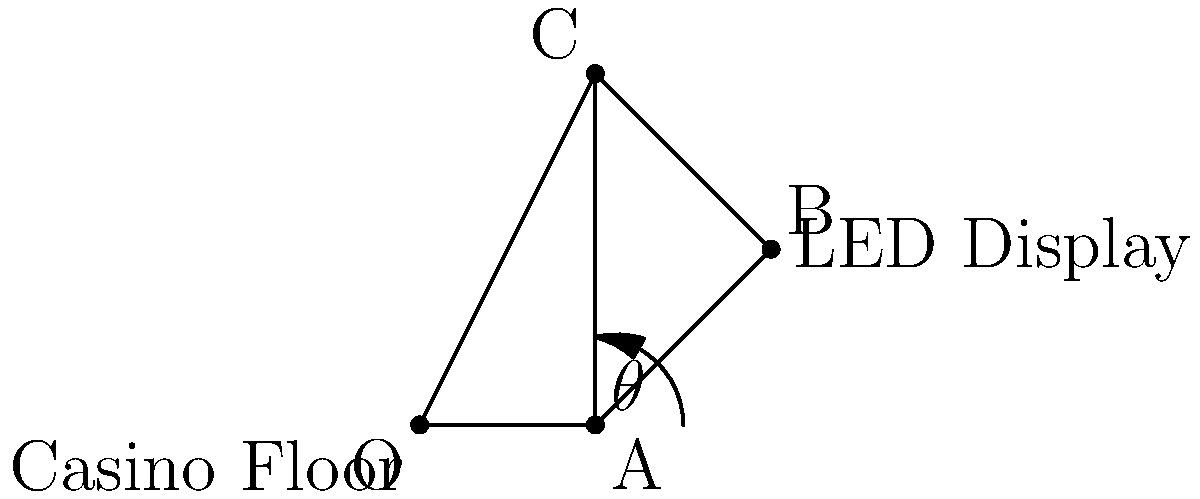In your state-of-the-art casino, you're installing a curved LED display to attract high-rollers. The display is mounted on a wall at point B, as shown in the diagram. To maximize visibility from the casino floor (represented by point O), you need to determine the optimal angle $\theta$ for the display. Given that OA = 2 units, AB = BC = $\sqrt{5}$ units, and AC = 4 units, calculate the optimal angle $\theta$ (in degrees) for maximum visibility. To find the optimal angle $\theta$ for maximum visibility, we need to follow these steps:

1) First, we need to recognize that for maximum visibility, the angle $\theta$ should be such that the LED display is perpendicular to the line of sight from point O to point B.

2) This means that angle OBA should be a right angle (90°).

3) In the triangle OAB:
   - We know OA = 2 units
   - AB = $\sqrt{5}$ units
   - We need to find angle BAO (which is our $\theta$)

4) We can use the trigonometric function tangent:
   $\tan \theta = \frac{\text{opposite}}{\text{adjacent}} = \frac{AB}{OA}$

5) Plugging in the values:
   $\tan \theta = \frac{\sqrt{5}}{2}$

6) To find $\theta$, we need to take the inverse tangent (arctangent):
   $\theta = \arctan(\frac{\sqrt{5}}{2})$

7) Converting this to degrees:
   $\theta \approx 63.43°$

Therefore, the optimal angle $\theta$ for the LED display to maximize visibility from the casino floor is approximately 63.43°.
Answer: $63.43°$ 